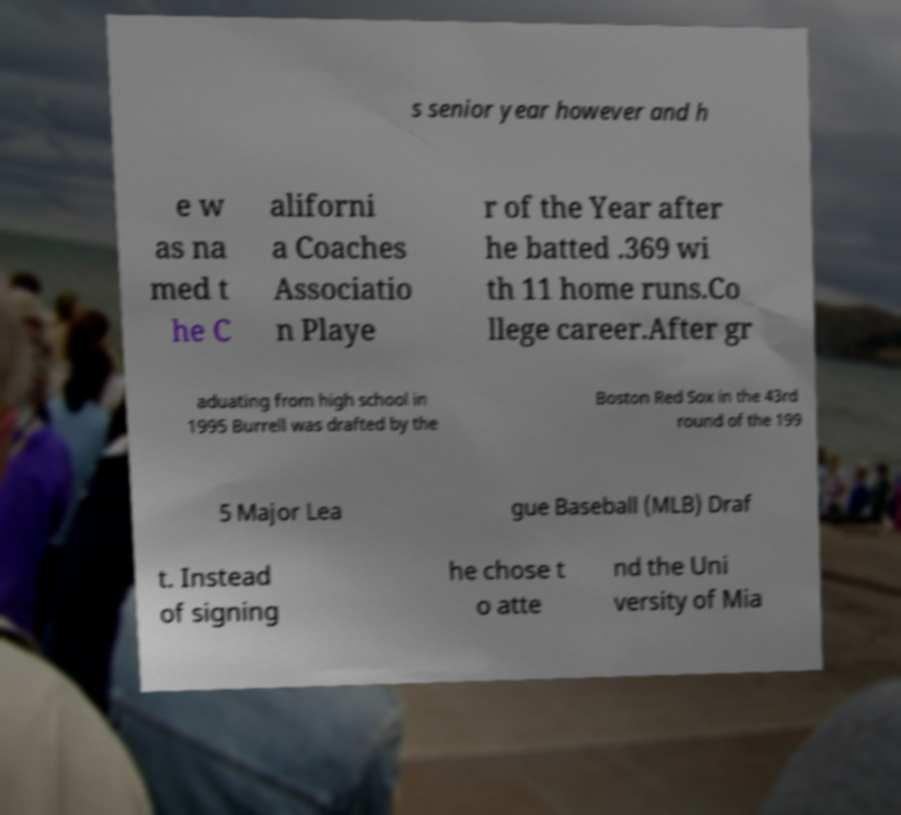I need the written content from this picture converted into text. Can you do that? s senior year however and h e w as na med t he C aliforni a Coaches Associatio n Playe r of the Year after he batted .369 wi th 11 home runs.Co llege career.After gr aduating from high school in 1995 Burrell was drafted by the Boston Red Sox in the 43rd round of the 199 5 Major Lea gue Baseball (MLB) Draf t. Instead of signing he chose t o atte nd the Uni versity of Mia 